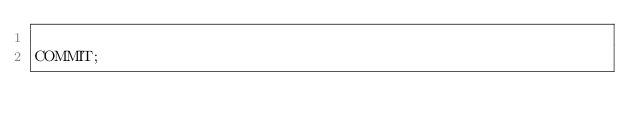<code> <loc_0><loc_0><loc_500><loc_500><_SQL_>
COMMIT;
</code> 